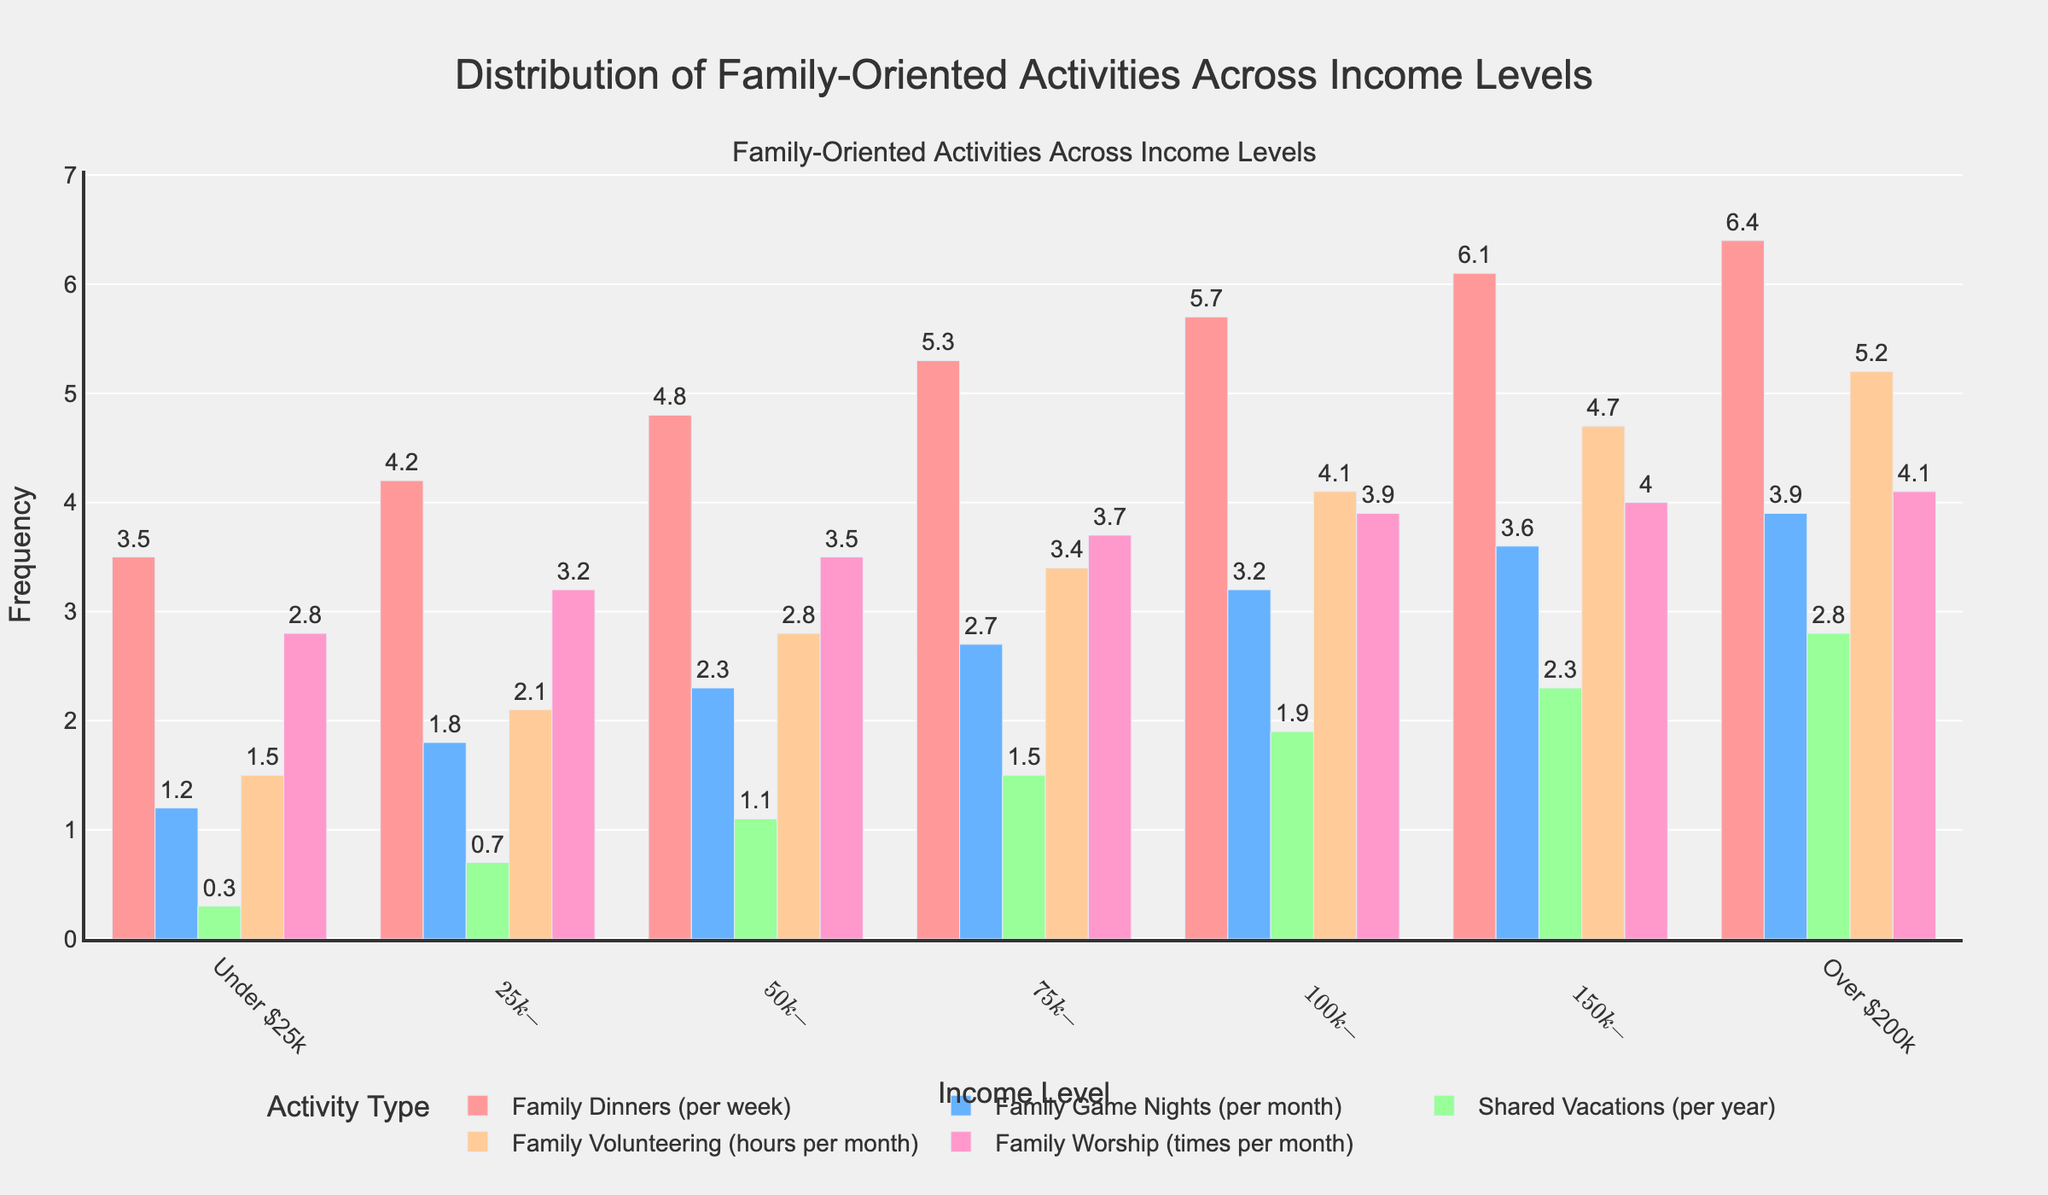What's the most frequent family-oriented activity across all income levels? By looking at the heights of the bars across all income levels, it's evident that "Family Dinners per week" has the highest bars overall, indicating the most frequent activity.
Answer: Family Dinners For the income level "$50k-$75k", how do the frequencies of Family Game Nights and Family Volunteering compare? At the "$50k-$75k" income level, Family Game Nights are 2.3 times per month and Family Volunteering is 2.8 hours per month. 2.8 is greater than 2.3, showing Family Volunteering is more frequent than Family Game Nights.
Answer: Family Volunteering is more frequent What is the combined frequency of Family Dinners and Family Worship for the "Over $200k" income level? At "Over $200k", Family Dinners occur 6.4 times per week and Family Worship 4.1 times per month. Adding these together: 6.4 + 4.1 = 10.5.
Answer: 10.5 Which income group shows the lowest frequency for Shared Vacations? Observing the heights of the bars for Shared Vacations, the "Under $25k" group has the shortest bar at 0.3 times per year.
Answer: Under $25k How does the frequency of Family Worship change from the "$75k-$100k" income level to the "$150k-$200k" income level? Family Worship is 3.7 times per month at "$75k-$100k" and 4.0 times per month at "$150k-$200k". The difference is 4.0 - 3.7 = 0.3, showing an increase.
Answer: Increases by 0.3 Between the "$25k-$50k" and "$100k-$150k" income levels, which one has a higher average frequency of all the activities combined? Calculating the average for "$25k-$50k": (4.2 + 1.8 + 0.7 + 2.1 + 3.2)/5 = 2.4. For "$100k-$150k": (5.7 + 3.2 + 1.9 + 4.1 + 3.9)/5 = 3.76. "$100k-$150k" is higher.
Answer: $100k-$150k Which two activities show the largest difference in frequency at the "Under $25k" income level? We need to find the largest difference among Family Dinners (3.5), Family Game Nights (1.2), Shared Vacations (0.3), Family Volunteering (1.5), and Family Worship (2.8). The difference between Family Dinners and Shared Vacations is 3.5 - 0.3 = 3.2, which is the largest.
Answer: Family Dinners and Shared Vacations What trend can be observed in the frequency of Family Volunteering as income level increases? Observing the bars representing Family Volunteering across income levels, the height generally increases from lower to higher income levels, indicating an increasing trend.
Answer: Increasing trend 